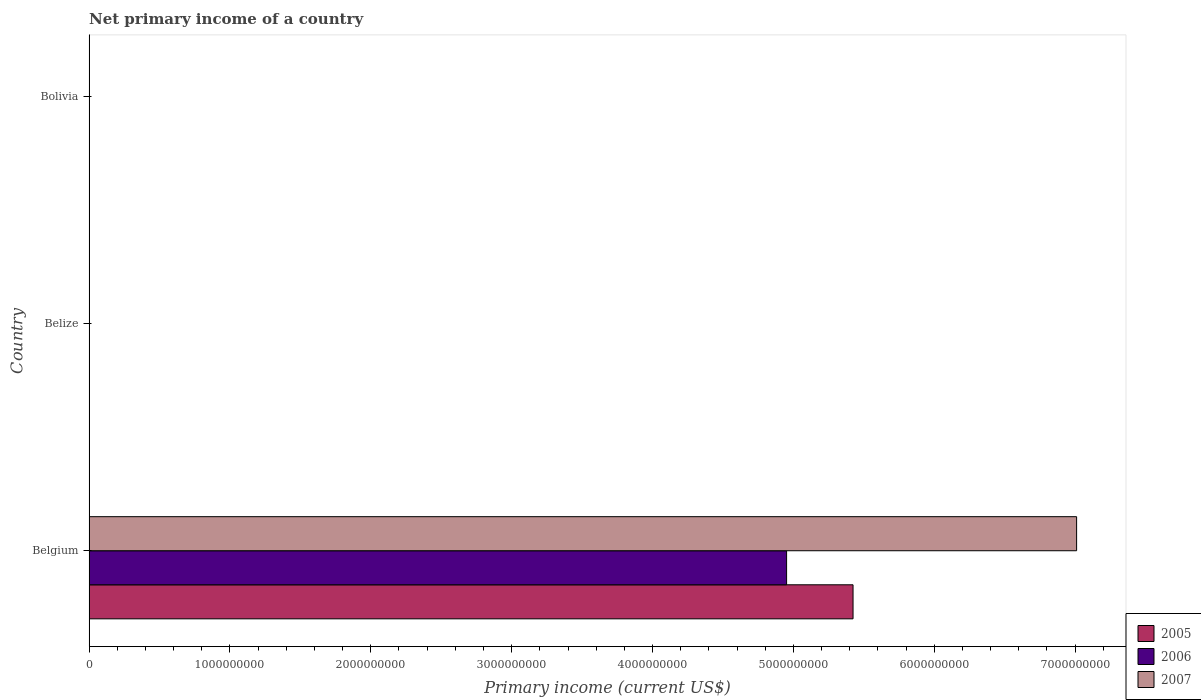How many different coloured bars are there?
Your answer should be compact. 3. How many bars are there on the 1st tick from the bottom?
Your response must be concise. 3. In how many cases, is the number of bars for a given country not equal to the number of legend labels?
Your answer should be very brief. 2. What is the primary income in 2005 in Belize?
Ensure brevity in your answer.  0. Across all countries, what is the maximum primary income in 2006?
Your answer should be compact. 4.95e+09. In which country was the primary income in 2005 maximum?
Your answer should be compact. Belgium. What is the total primary income in 2007 in the graph?
Give a very brief answer. 7.01e+09. What is the difference between the primary income in 2007 in Belize and the primary income in 2005 in Belgium?
Offer a very short reply. -5.42e+09. What is the average primary income in 2006 per country?
Keep it short and to the point. 1.65e+09. What is the difference between the primary income in 2007 and primary income in 2006 in Belgium?
Offer a terse response. 2.06e+09. In how many countries, is the primary income in 2005 greater than 5200000000 US$?
Provide a short and direct response. 1. What is the difference between the highest and the lowest primary income in 2006?
Provide a short and direct response. 4.95e+09. Is it the case that in every country, the sum of the primary income in 2006 and primary income in 2007 is greater than the primary income in 2005?
Make the answer very short. No. What is the difference between two consecutive major ticks on the X-axis?
Your response must be concise. 1.00e+09. Does the graph contain grids?
Offer a very short reply. No. Where does the legend appear in the graph?
Offer a very short reply. Bottom right. How many legend labels are there?
Keep it short and to the point. 3. What is the title of the graph?
Give a very brief answer. Net primary income of a country. Does "2012" appear as one of the legend labels in the graph?
Offer a very short reply. No. What is the label or title of the X-axis?
Your response must be concise. Primary income (current US$). What is the label or title of the Y-axis?
Keep it short and to the point. Country. What is the Primary income (current US$) in 2005 in Belgium?
Provide a short and direct response. 5.42e+09. What is the Primary income (current US$) of 2006 in Belgium?
Provide a succinct answer. 4.95e+09. What is the Primary income (current US$) of 2007 in Belgium?
Your answer should be very brief. 7.01e+09. What is the Primary income (current US$) in 2007 in Belize?
Your answer should be very brief. 0. What is the Primary income (current US$) in 2006 in Bolivia?
Provide a short and direct response. 0. What is the Primary income (current US$) in 2007 in Bolivia?
Your response must be concise. 0. Across all countries, what is the maximum Primary income (current US$) of 2005?
Your response must be concise. 5.42e+09. Across all countries, what is the maximum Primary income (current US$) in 2006?
Offer a terse response. 4.95e+09. Across all countries, what is the maximum Primary income (current US$) of 2007?
Provide a succinct answer. 7.01e+09. Across all countries, what is the minimum Primary income (current US$) of 2005?
Make the answer very short. 0. Across all countries, what is the minimum Primary income (current US$) of 2006?
Provide a short and direct response. 0. What is the total Primary income (current US$) in 2005 in the graph?
Your answer should be very brief. 5.42e+09. What is the total Primary income (current US$) of 2006 in the graph?
Keep it short and to the point. 4.95e+09. What is the total Primary income (current US$) in 2007 in the graph?
Your answer should be very brief. 7.01e+09. What is the average Primary income (current US$) in 2005 per country?
Provide a short and direct response. 1.81e+09. What is the average Primary income (current US$) in 2006 per country?
Offer a terse response. 1.65e+09. What is the average Primary income (current US$) of 2007 per country?
Ensure brevity in your answer.  2.34e+09. What is the difference between the Primary income (current US$) of 2005 and Primary income (current US$) of 2006 in Belgium?
Your response must be concise. 4.72e+08. What is the difference between the Primary income (current US$) of 2005 and Primary income (current US$) of 2007 in Belgium?
Make the answer very short. -1.59e+09. What is the difference between the Primary income (current US$) of 2006 and Primary income (current US$) of 2007 in Belgium?
Your response must be concise. -2.06e+09. What is the difference between the highest and the lowest Primary income (current US$) of 2005?
Your response must be concise. 5.42e+09. What is the difference between the highest and the lowest Primary income (current US$) in 2006?
Offer a terse response. 4.95e+09. What is the difference between the highest and the lowest Primary income (current US$) in 2007?
Offer a very short reply. 7.01e+09. 